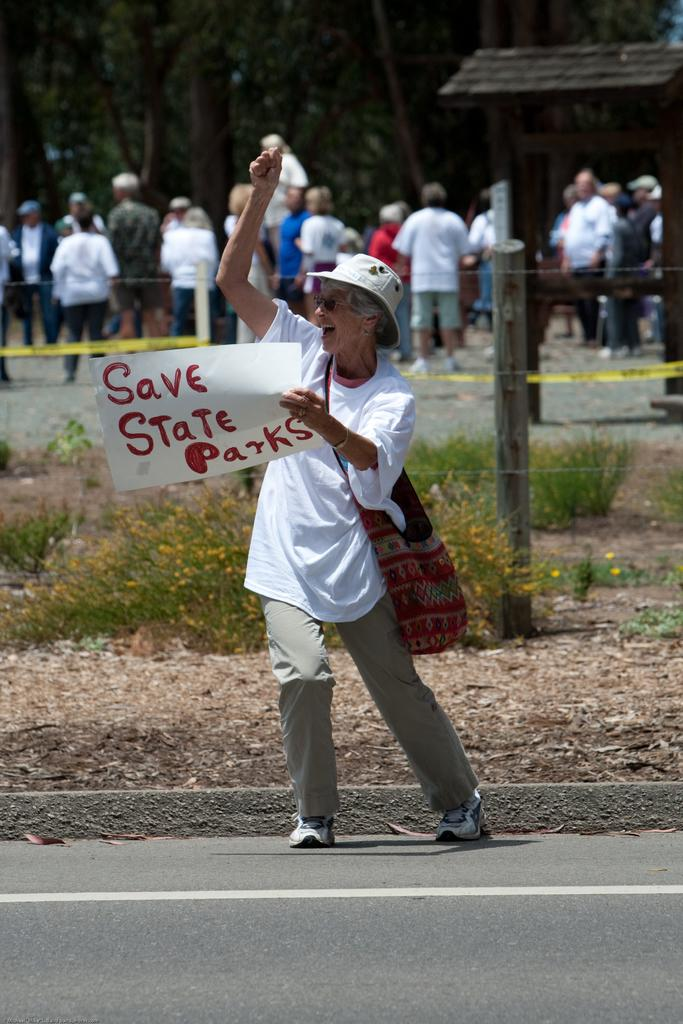What is the person in the image holding? The person is holding a paper. Where is the person standing in the image? The person is standing on the road. What can be seen in the background of the image? In the background, there are plants, a wooden pole, wire fencing, people, trees, and an object. What type of animal is the person talking to in the image? There is no animal present in the image, and the person is not talking to anyone. 